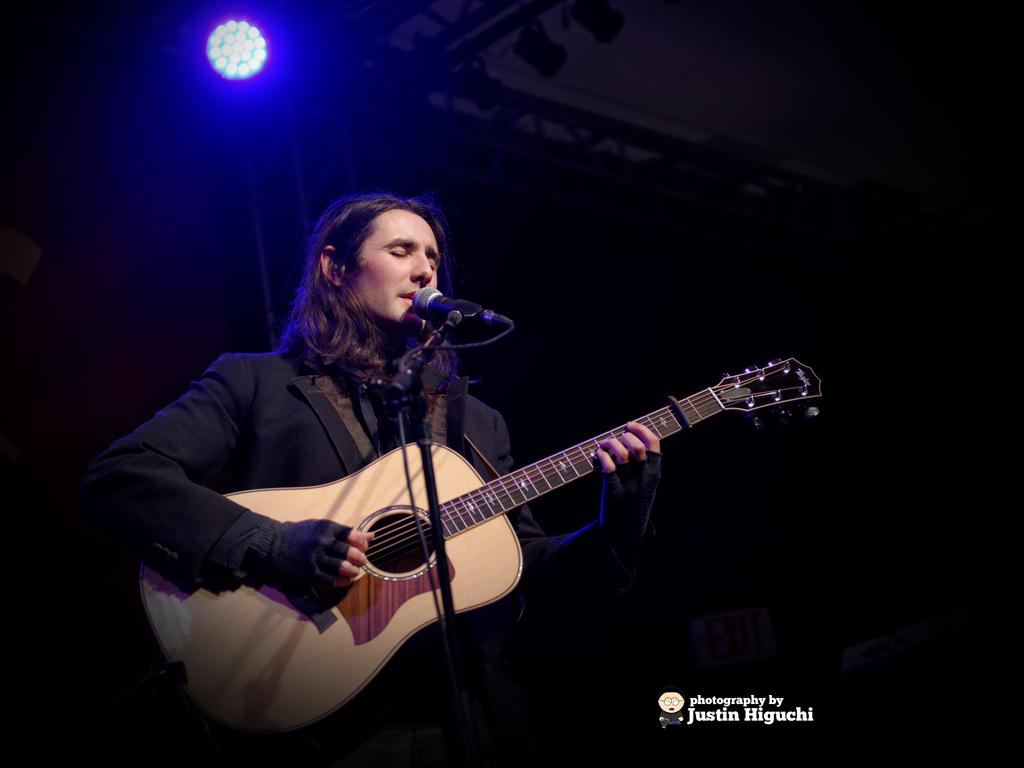Who is the main subject in the image? There is a man in the image. What is the man doing in the image? The man is singing and playing a guitar. What is the man holding in the image? The man is holding a microphone. How would you describe the background of the image? The background of the image is blurry, and there is light visible in it. What type of plant is growing on the man's head in the image? There is no plant growing on the man's head in the image. How does the man's mother feel about his performance in the image? The image does not provide any information about the man's mother or her feelings about his performance. 